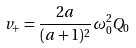<formula> <loc_0><loc_0><loc_500><loc_500>v _ { + } = \frac { 2 a } { ( a + 1 ) ^ { 2 } } \omega _ { 0 } ^ { 2 } Q _ { 0 }</formula> 